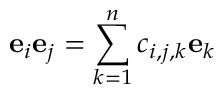Convert formula to latex. <formula><loc_0><loc_0><loc_500><loc_500>e _ { i } e _ { j } = \sum _ { k = 1 } ^ { n } c _ { i , j , k } e _ { k }</formula> 